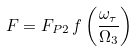<formula> <loc_0><loc_0><loc_500><loc_500>F = F _ { P 2 } \, f \left ( \frac { \omega _ { \tau } } { \Omega _ { 3 } } \right )</formula> 